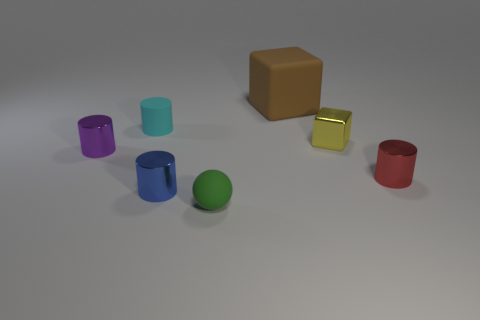There is a small metallic object that is both right of the small green ball and on the left side of the red object; what shape is it?
Ensure brevity in your answer.  Cube. Is there a green ball that has the same material as the tiny purple thing?
Keep it short and to the point. No. What color is the small rubber sphere that is in front of the blue object?
Keep it short and to the point. Green. Is the shape of the large thing the same as the metallic object that is behind the purple thing?
Ensure brevity in your answer.  Yes. There is a blue cylinder that is the same material as the purple cylinder; what size is it?
Provide a short and direct response. Small. Does the rubber thing on the right side of the green matte sphere have the same shape as the yellow thing?
Your answer should be compact. Yes. What number of matte balls have the same size as the red shiny object?
Your answer should be very brief. 1. There is a tiny rubber thing in front of the red shiny thing; is there a big thing that is behind it?
Your answer should be very brief. Yes. How many things are either cylinders that are in front of the small cyan rubber cylinder or cyan rubber cylinders?
Give a very brief answer. 4. How many big gray rubber cylinders are there?
Your answer should be compact. 0. 